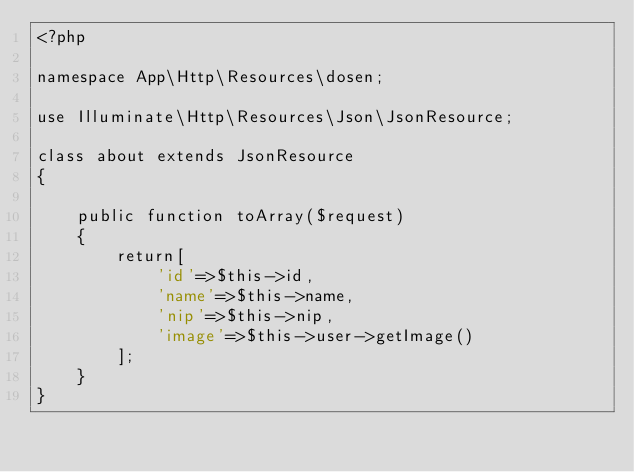Convert code to text. <code><loc_0><loc_0><loc_500><loc_500><_PHP_><?php

namespace App\Http\Resources\dosen;

use Illuminate\Http\Resources\Json\JsonResource;

class about extends JsonResource
{
    
    public function toArray($request)
    {
        return[
            'id'=>$this->id,
            'name'=>$this->name,
            'nip'=>$this->nip, 
            'image'=>$this->user->getImage()
        ];
    }
}
</code> 